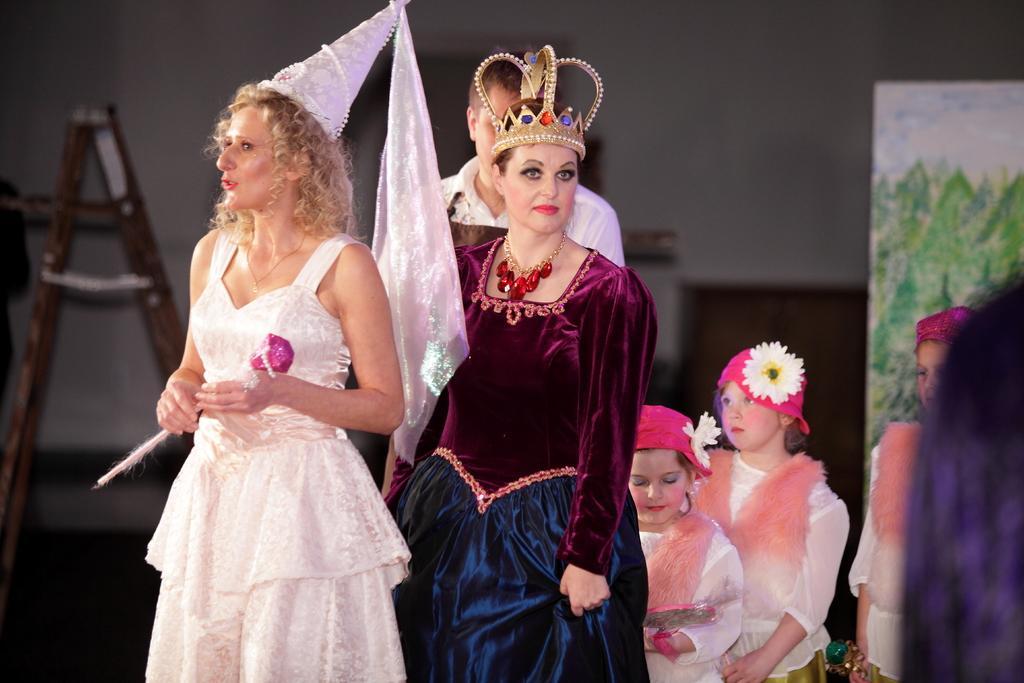How would you summarize this image in a sentence or two? In this image we can see two women, kids and a man are standing and among them a woman has crown on her head and the another woman has hat on her head and holding an object in the hands and there are flowers on the caps on the kids heads. In the background we can see ladder, wall, board and other objects. 